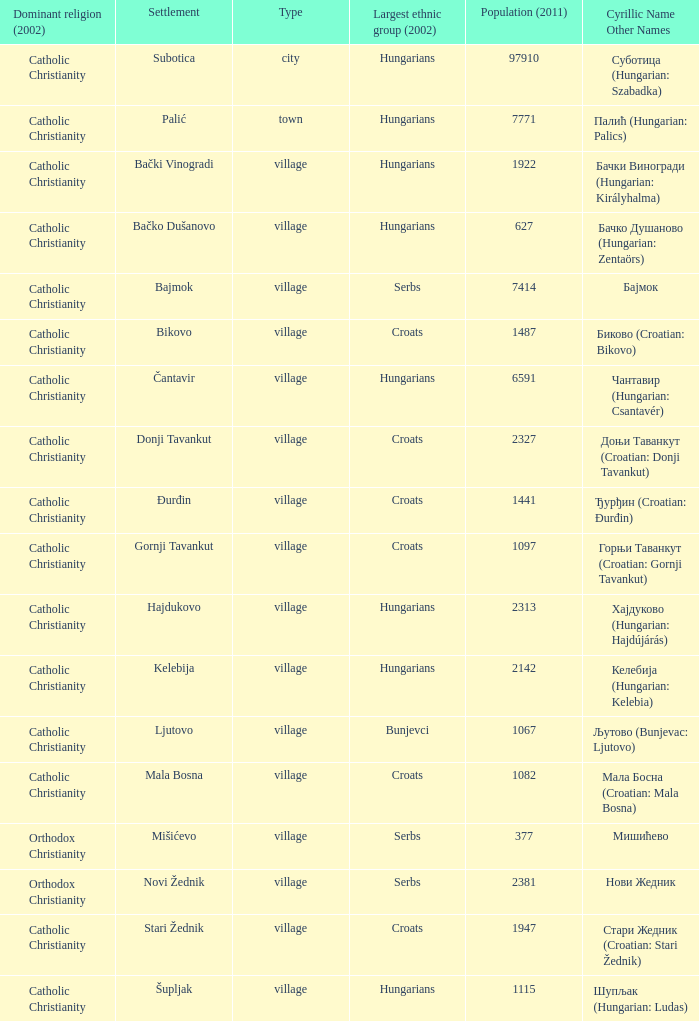What is the dominant religion in Gornji Tavankut? Catholic Christianity. 